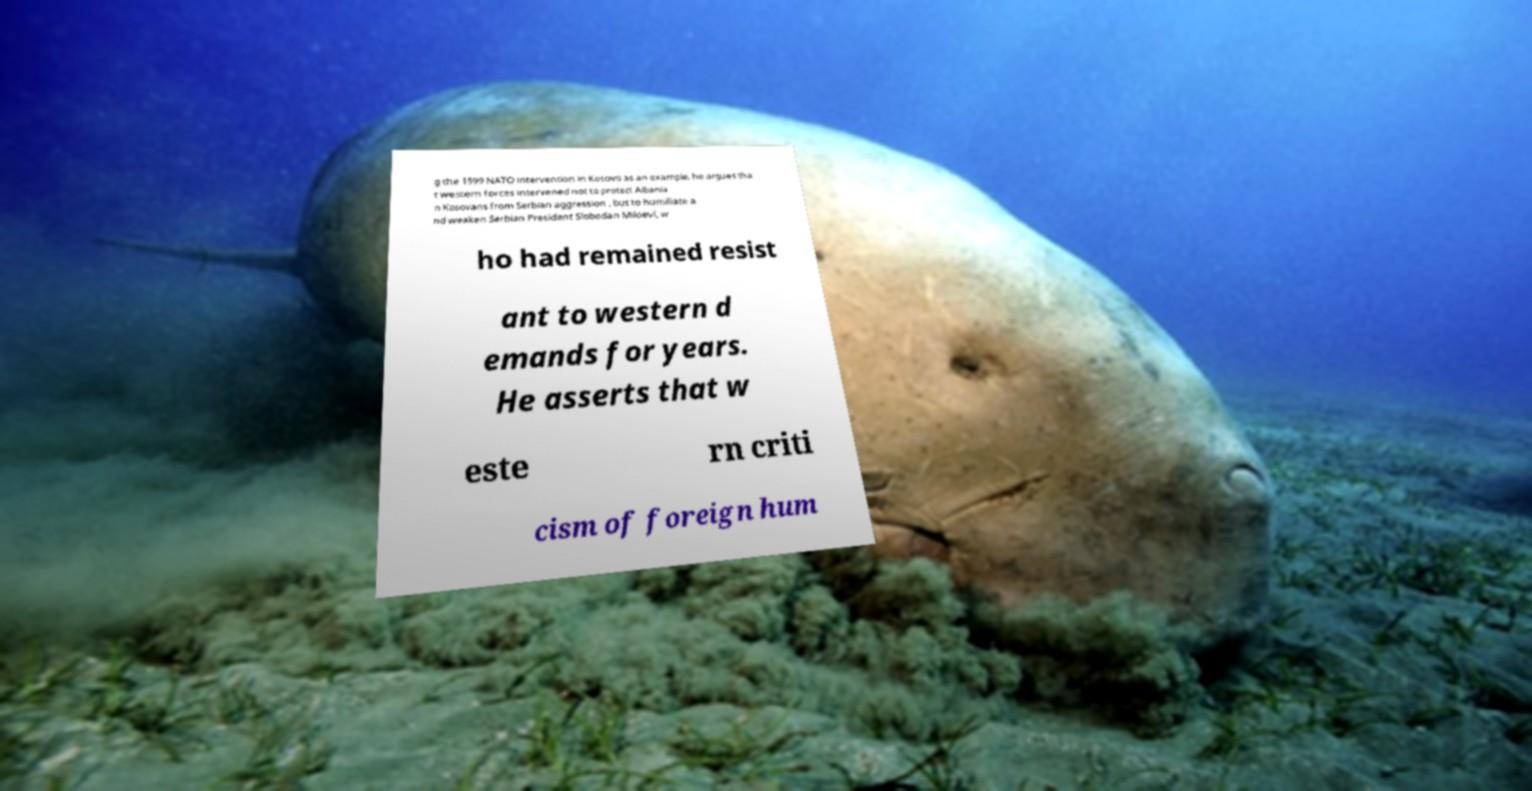Please identify and transcribe the text found in this image. g the 1999 NATO intervention in Kosovo as an example, he argues tha t western forces intervened not to protect Albania n Kosovans from Serbian aggression , but to humiliate a nd weaken Serbian President Slobodan Miloevi, w ho had remained resist ant to western d emands for years. He asserts that w este rn criti cism of foreign hum 